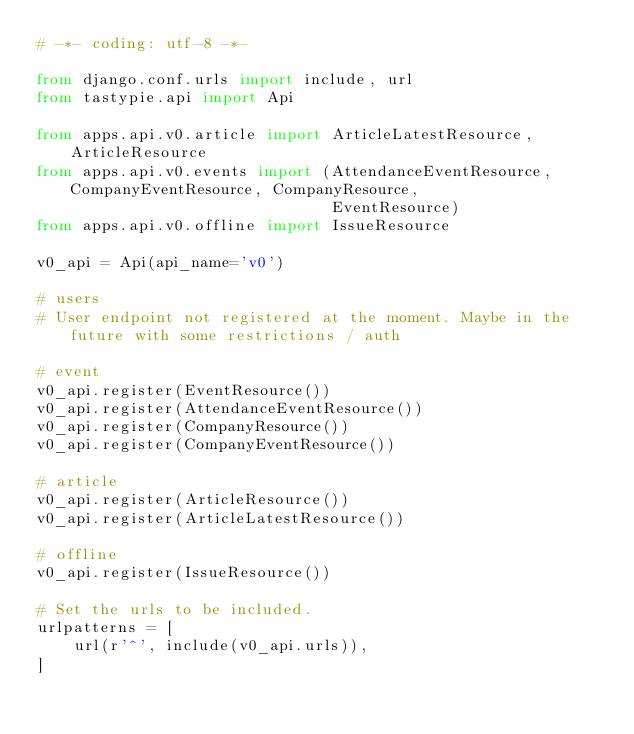Convert code to text. <code><loc_0><loc_0><loc_500><loc_500><_Python_># -*- coding: utf-8 -*-

from django.conf.urls import include, url
from tastypie.api import Api

from apps.api.v0.article import ArticleLatestResource, ArticleResource
from apps.api.v0.events import (AttendanceEventResource, CompanyEventResource, CompanyResource,
                                EventResource)
from apps.api.v0.offline import IssueResource

v0_api = Api(api_name='v0')

# users
# User endpoint not registered at the moment. Maybe in the future with some restrictions / auth

# event
v0_api.register(EventResource())
v0_api.register(AttendanceEventResource())
v0_api.register(CompanyResource())
v0_api.register(CompanyEventResource())

# article
v0_api.register(ArticleResource())
v0_api.register(ArticleLatestResource())

# offline
v0_api.register(IssueResource())

# Set the urls to be included.
urlpatterns = [
    url(r'^', include(v0_api.urls)),
]
</code> 